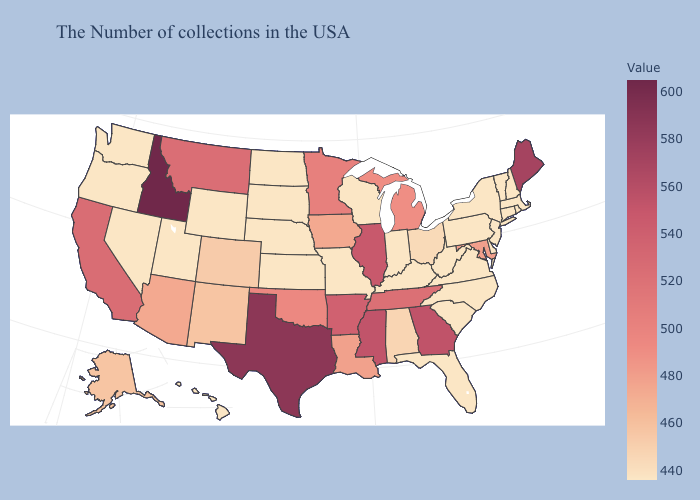Which states have the highest value in the USA?
Short answer required. Idaho. Does Rhode Island have the highest value in the Northeast?
Be succinct. No. Among the states that border Arkansas , does Texas have the lowest value?
Concise answer only. No. Among the states that border Wisconsin , which have the lowest value?
Write a very short answer. Iowa. Which states have the highest value in the USA?
Concise answer only. Idaho. Does Virginia have the highest value in the USA?
Write a very short answer. No. Among the states that border Florida , does Alabama have the highest value?
Concise answer only. No. Does Maryland have a lower value than New Jersey?
Be succinct. No. Does Iowa have the highest value in the MidWest?
Answer briefly. No. 